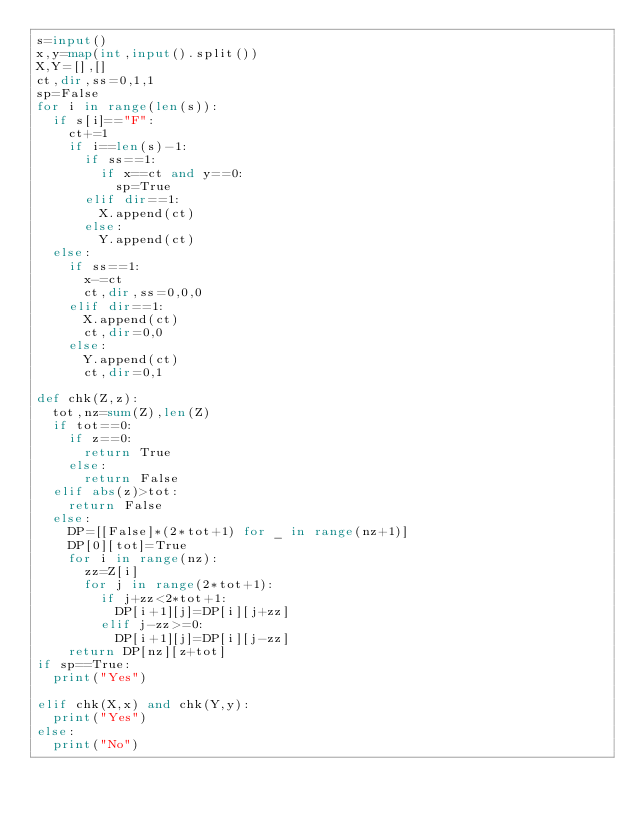Convert code to text. <code><loc_0><loc_0><loc_500><loc_500><_Python_>s=input()
x,y=map(int,input().split())
X,Y=[],[]
ct,dir,ss=0,1,1
sp=False
for i in range(len(s)):
  if s[i]=="F":
    ct+=1
    if i==len(s)-1:
      if ss==1:
        if x==ct and y==0:
          sp=True
      elif dir==1:
        X.append(ct)
      else:
        Y.append(ct)
  else:
    if ss==1:
      x-=ct
      ct,dir,ss=0,0,0
    elif dir==1:
      X.append(ct)
      ct,dir=0,0
    else:
      Y.append(ct)
      ct,dir=0,1

def chk(Z,z):
  tot,nz=sum(Z),len(Z)
  if tot==0:
    if z==0:
      return True
    else:
      return False
  elif abs(z)>tot:
    return False
  else:
    DP=[[False]*(2*tot+1) for _ in range(nz+1)]
    DP[0][tot]=True
    for i in range(nz):
      zz=Z[i]
      for j in range(2*tot+1):
        if j+zz<2*tot+1:
          DP[i+1][j]=DP[i][j+zz]
        elif j-zz>=0:
          DP[i+1][j]=DP[i][j-zz]
    return DP[nz][z+tot]
if sp==True:
  print("Yes")

elif chk(X,x) and chk(Y,y):
  print("Yes")
else:
  print("No")


</code> 